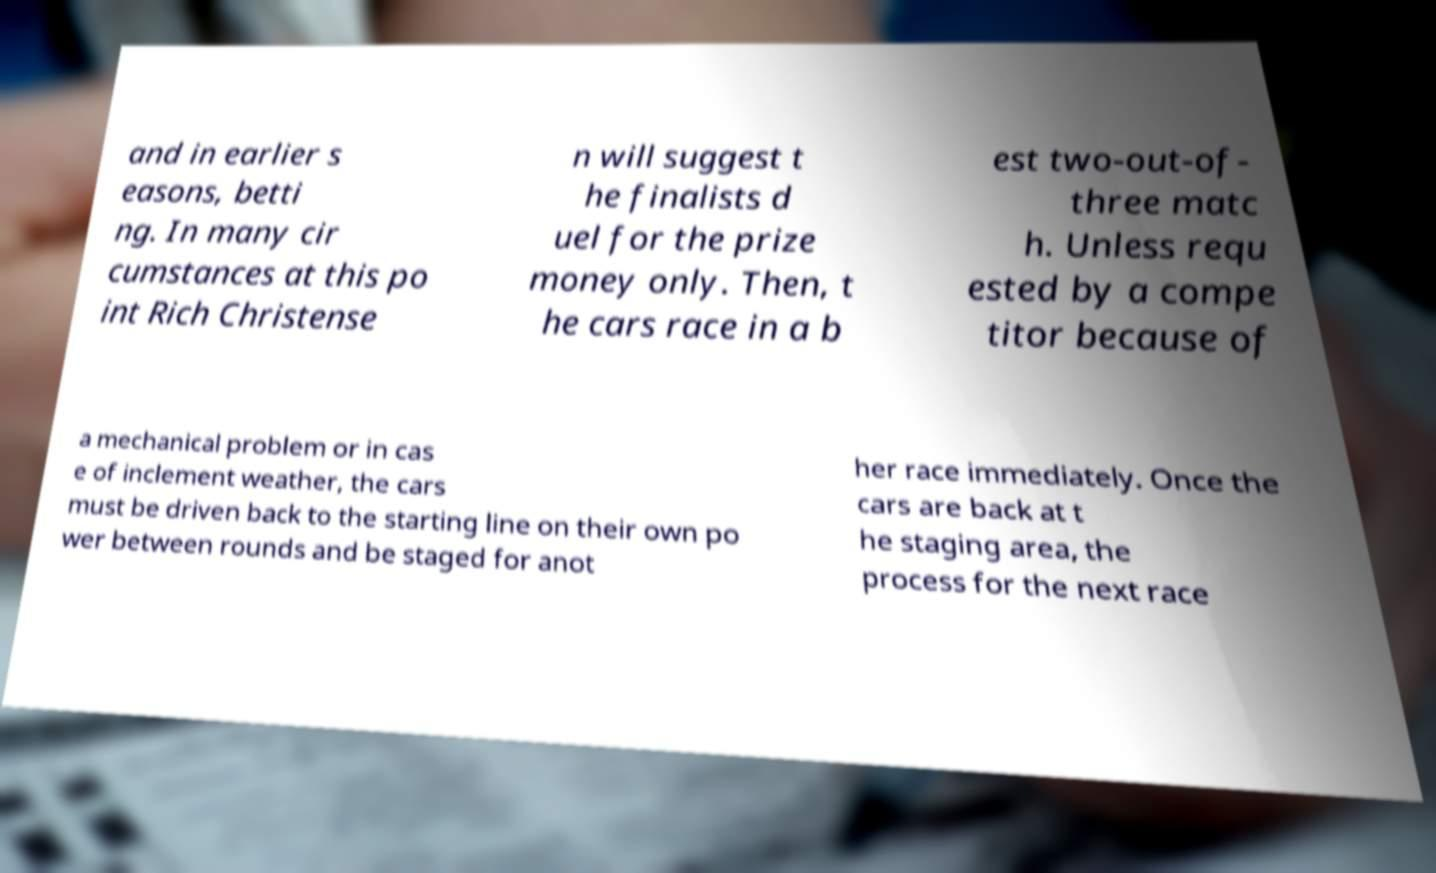I need the written content from this picture converted into text. Can you do that? and in earlier s easons, betti ng. In many cir cumstances at this po int Rich Christense n will suggest t he finalists d uel for the prize money only. Then, t he cars race in a b est two-out-of- three matc h. Unless requ ested by a compe titor because of a mechanical problem or in cas e of inclement weather, the cars must be driven back to the starting line on their own po wer between rounds and be staged for anot her race immediately. Once the cars are back at t he staging area, the process for the next race 